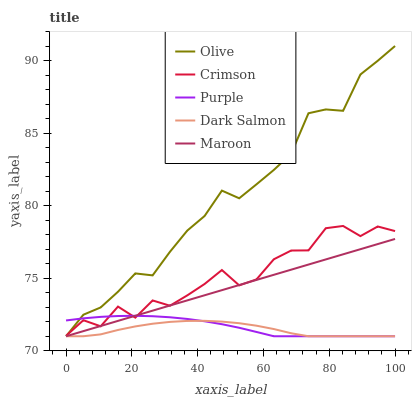Does Dark Salmon have the minimum area under the curve?
Answer yes or no. Yes. Does Olive have the maximum area under the curve?
Answer yes or no. Yes. Does Crimson have the minimum area under the curve?
Answer yes or no. No. Does Crimson have the maximum area under the curve?
Answer yes or no. No. Is Maroon the smoothest?
Answer yes or no. Yes. Is Crimson the roughest?
Answer yes or no. Yes. Is Crimson the smoothest?
Answer yes or no. No. Is Maroon the roughest?
Answer yes or no. No. Does Olive have the lowest value?
Answer yes or no. Yes. Does Crimson have the lowest value?
Answer yes or no. No. Does Olive have the highest value?
Answer yes or no. Yes. Does Crimson have the highest value?
Answer yes or no. No. Is Dark Salmon less than Crimson?
Answer yes or no. Yes. Is Crimson greater than Dark Salmon?
Answer yes or no. Yes. Does Purple intersect Crimson?
Answer yes or no. Yes. Is Purple less than Crimson?
Answer yes or no. No. Is Purple greater than Crimson?
Answer yes or no. No. Does Dark Salmon intersect Crimson?
Answer yes or no. No. 